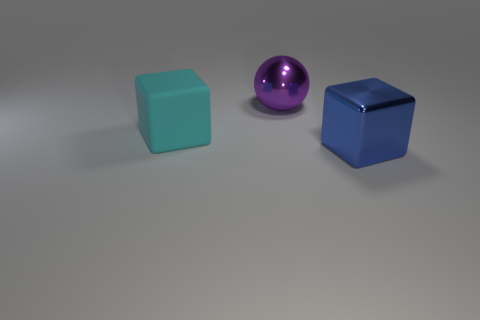Add 1 metallic balls. How many objects exist? 4 Subtract all green rubber spheres. Subtract all big blue objects. How many objects are left? 2 Add 3 large balls. How many large balls are left? 4 Add 1 large matte things. How many large matte things exist? 2 Subtract 0 red spheres. How many objects are left? 3 Subtract all cubes. How many objects are left? 1 